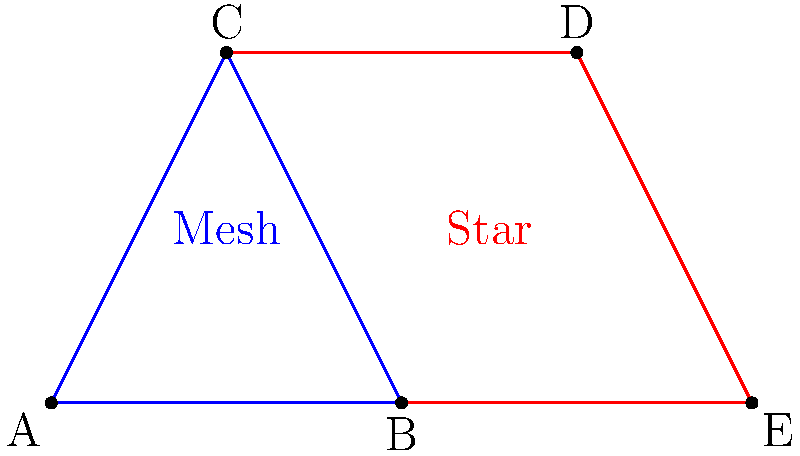In the network topology comparison shown, what is the ratio of the number of connections in the star topology (red) to the number of connections in the mesh topology (blue)? How does this ratio change as we add more nodes to each topology, and what implications does this have for network scalability? Let's analyze this step-by-step:

1. Count the connections:
   - Mesh topology (blue): 3 connections (A-B, B-C, C-A)
   - Star topology (red): 4 connections (C-D, D-E, E-B, B-C)

2. Calculate the ratio:
   $\frac{\text{Star connections}}{\text{Mesh connections}} = \frac{4}{3} \approx 1.33$

3. Scaling analysis:
   - For a mesh topology with $n$ nodes, the number of connections is $\frac{n(n-1)}{2}$
   - For a star topology with $n$ nodes, the number of connections is $n-1$

4. As $n$ increases:
   - Mesh connections grow quadratically: $O(n^2)$
   - Star connections grow linearly: $O(n)$

5. The ratio as $n$ approaches infinity:
   $\lim_{n \to \infty} \frac{n-1}{\frac{n(n-1)}{2}} = \lim_{n \to \infty} \frac{2}{n} = 0$

6. Implications for scalability:
   - Star topologies scale more efficiently in terms of connection count
   - Mesh topologies provide more redundancy but at the cost of increased complexity

This analysis demonstrates that while our platform's star topology may initially have more connections, it becomes increasingly efficient as the network grows, offering better scalability for large-scale deployments.
Answer: Initial ratio: 4:3. As nodes increase, star topology becomes more efficient (O(n) vs O(n^2)), offering better scalability. 